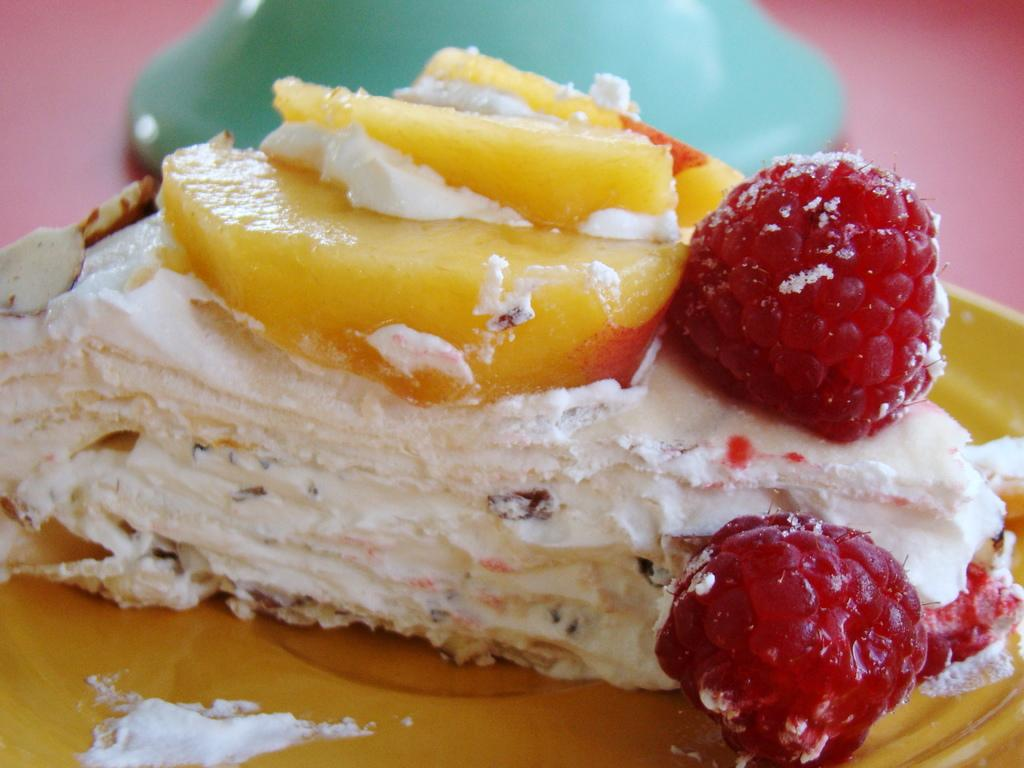What type of food can be seen in the image? There is a pastry in the image. What is on top of the pastry? There are fruits on the pastry. Where can you find the dolls in the image? There are no dolls present in the image. 